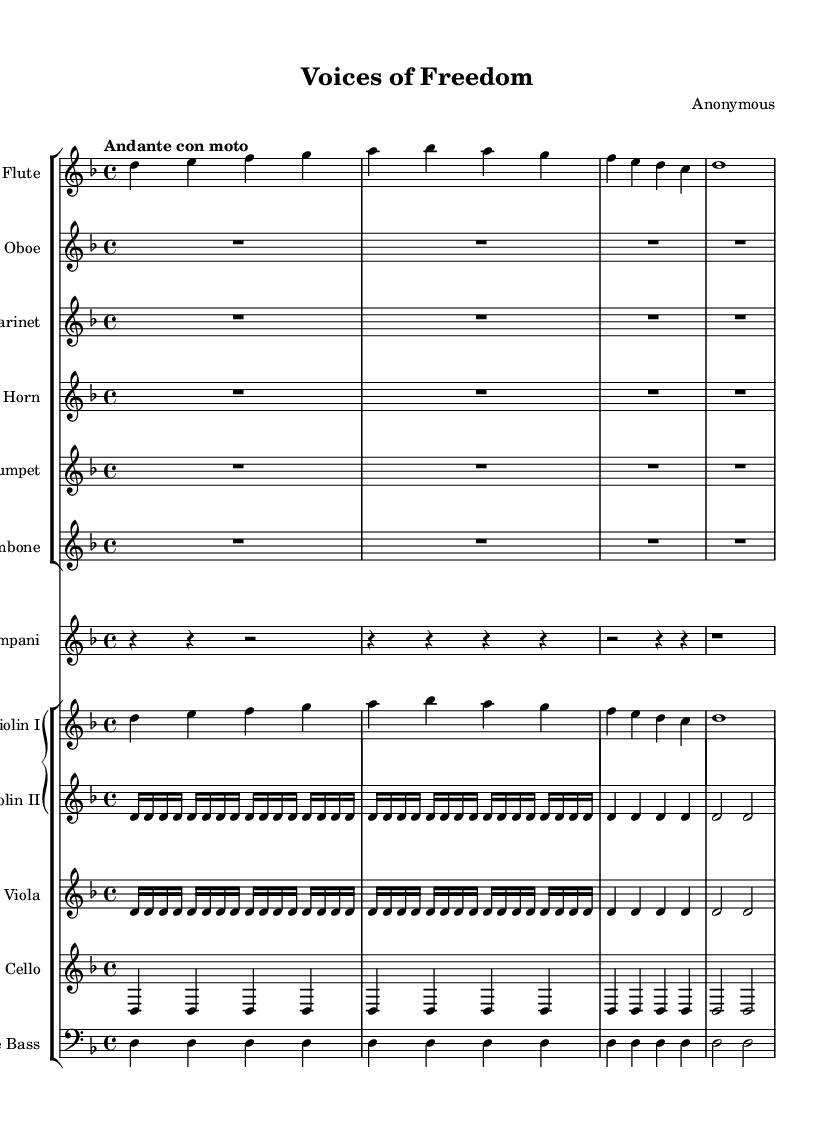What is the key signature of this music? The key signature is identified by the presence of one flat (B flat) in the key signature area before the staff lines, indicating that the music is composed in D minor.
Answer: D minor What is the time signature of this music? The time signature is indicated in the beginning of the piece, showing a "4 over 4" which means there are four beats in every measure, and each quarter note receives one beat.
Answer: 4/4 What tempo marking is indicated in the score? The tempo marking is located at the beginning of the music, specifying "Andante con moto," which refers to a moderately slow but flowing speed of performance.
Answer: Andante con moto How many different instrument groups are present in the score? The score is divided into two main groups: one group for woodwinds and brass instruments and another group for strings and percussion instruments. Counting these, we find there are two groups.
Answer: 2 Which instrument has the highest pitch in this orchestral score? To determine the highest pitch instrument, we compare the ranges of the instruments listed. The flute typically plays at higher pitches than the other instruments, especially compared to violins and brass.
Answer: Flute How many measures are present in the flute part? By analyzing the flute section of the score, we count the number of measures present in that specific line, which total four measures in this simple theme.
Answer: 4 What type of musical form does this composition exhibit? The piece showcases a simple binary form, where we can identify an A section (the initial phrase) followed by a repeat or variation in the orchestration. Thus, it can be analyzed to be structured as A-A.
Answer: Binary form 